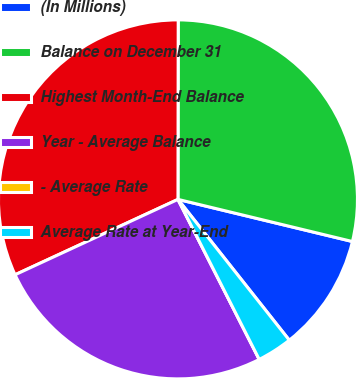Convert chart. <chart><loc_0><loc_0><loc_500><loc_500><pie_chart><fcel>(In Millions)<fcel>Balance on December 31<fcel>Highest Month-End Balance<fcel>Year - Average Balance<fcel>- Average Rate<fcel>Average Rate at Year-End<nl><fcel>10.58%<fcel>28.75%<fcel>31.92%<fcel>25.58%<fcel>0.0%<fcel>3.17%<nl></chart> 